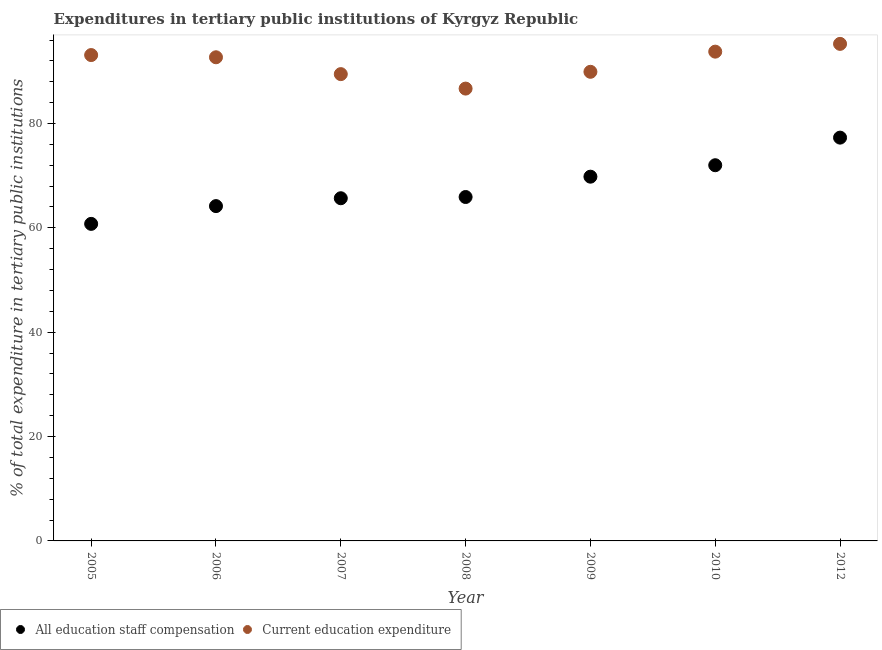Is the number of dotlines equal to the number of legend labels?
Your answer should be very brief. Yes. What is the expenditure in staff compensation in 2005?
Ensure brevity in your answer.  60.76. Across all years, what is the maximum expenditure in staff compensation?
Provide a short and direct response. 77.29. Across all years, what is the minimum expenditure in staff compensation?
Provide a succinct answer. 60.76. In which year was the expenditure in staff compensation maximum?
Your response must be concise. 2012. What is the total expenditure in education in the graph?
Give a very brief answer. 640.92. What is the difference between the expenditure in staff compensation in 2005 and that in 2006?
Provide a short and direct response. -3.41. What is the difference between the expenditure in education in 2007 and the expenditure in staff compensation in 2012?
Keep it short and to the point. 12.17. What is the average expenditure in staff compensation per year?
Give a very brief answer. 67.95. In the year 2005, what is the difference between the expenditure in staff compensation and expenditure in education?
Provide a short and direct response. -32.35. In how many years, is the expenditure in education greater than 48 %?
Your response must be concise. 7. What is the ratio of the expenditure in staff compensation in 2007 to that in 2012?
Give a very brief answer. 0.85. Is the difference between the expenditure in education in 2005 and 2006 greater than the difference between the expenditure in staff compensation in 2005 and 2006?
Provide a short and direct response. Yes. What is the difference between the highest and the second highest expenditure in staff compensation?
Provide a short and direct response. 5.29. What is the difference between the highest and the lowest expenditure in education?
Give a very brief answer. 8.57. In how many years, is the expenditure in staff compensation greater than the average expenditure in staff compensation taken over all years?
Your answer should be very brief. 3. Is the expenditure in staff compensation strictly less than the expenditure in education over the years?
Your answer should be very brief. Yes. How many years are there in the graph?
Offer a terse response. 7. What is the difference between two consecutive major ticks on the Y-axis?
Make the answer very short. 20. Are the values on the major ticks of Y-axis written in scientific E-notation?
Provide a succinct answer. No. Does the graph contain grids?
Your answer should be very brief. No. How many legend labels are there?
Provide a short and direct response. 2. How are the legend labels stacked?
Offer a very short reply. Horizontal. What is the title of the graph?
Offer a very short reply. Expenditures in tertiary public institutions of Kyrgyz Republic. What is the label or title of the X-axis?
Your response must be concise. Year. What is the label or title of the Y-axis?
Provide a succinct answer. % of total expenditure in tertiary public institutions. What is the % of total expenditure in tertiary public institutions in All education staff compensation in 2005?
Provide a succinct answer. 60.76. What is the % of total expenditure in tertiary public institutions of Current education expenditure in 2005?
Offer a terse response. 93.12. What is the % of total expenditure in tertiary public institutions of All education staff compensation in 2006?
Ensure brevity in your answer.  64.17. What is the % of total expenditure in tertiary public institutions of Current education expenditure in 2006?
Your response must be concise. 92.7. What is the % of total expenditure in tertiary public institutions of All education staff compensation in 2007?
Keep it short and to the point. 65.68. What is the % of total expenditure in tertiary public institutions of Current education expenditure in 2007?
Give a very brief answer. 89.47. What is the % of total expenditure in tertiary public institutions in All education staff compensation in 2008?
Offer a terse response. 65.91. What is the % of total expenditure in tertiary public institutions in Current education expenditure in 2008?
Your answer should be very brief. 86.69. What is the % of total expenditure in tertiary public institutions in All education staff compensation in 2009?
Give a very brief answer. 69.81. What is the % of total expenditure in tertiary public institutions of Current education expenditure in 2009?
Your answer should be very brief. 89.91. What is the % of total expenditure in tertiary public institutions of All education staff compensation in 2010?
Make the answer very short. 72.01. What is the % of total expenditure in tertiary public institutions of Current education expenditure in 2010?
Provide a short and direct response. 93.77. What is the % of total expenditure in tertiary public institutions in All education staff compensation in 2012?
Provide a short and direct response. 77.29. What is the % of total expenditure in tertiary public institutions of Current education expenditure in 2012?
Keep it short and to the point. 95.26. Across all years, what is the maximum % of total expenditure in tertiary public institutions of All education staff compensation?
Make the answer very short. 77.29. Across all years, what is the maximum % of total expenditure in tertiary public institutions in Current education expenditure?
Your answer should be very brief. 95.26. Across all years, what is the minimum % of total expenditure in tertiary public institutions of All education staff compensation?
Keep it short and to the point. 60.76. Across all years, what is the minimum % of total expenditure in tertiary public institutions in Current education expenditure?
Provide a succinct answer. 86.69. What is the total % of total expenditure in tertiary public institutions in All education staff compensation in the graph?
Provide a succinct answer. 475.64. What is the total % of total expenditure in tertiary public institutions in Current education expenditure in the graph?
Your response must be concise. 640.92. What is the difference between the % of total expenditure in tertiary public institutions in All education staff compensation in 2005 and that in 2006?
Your response must be concise. -3.41. What is the difference between the % of total expenditure in tertiary public institutions of Current education expenditure in 2005 and that in 2006?
Your answer should be compact. 0.42. What is the difference between the % of total expenditure in tertiary public institutions in All education staff compensation in 2005 and that in 2007?
Keep it short and to the point. -4.91. What is the difference between the % of total expenditure in tertiary public institutions of Current education expenditure in 2005 and that in 2007?
Ensure brevity in your answer.  3.65. What is the difference between the % of total expenditure in tertiary public institutions in All education staff compensation in 2005 and that in 2008?
Your response must be concise. -5.15. What is the difference between the % of total expenditure in tertiary public institutions of Current education expenditure in 2005 and that in 2008?
Your response must be concise. 6.43. What is the difference between the % of total expenditure in tertiary public institutions in All education staff compensation in 2005 and that in 2009?
Make the answer very short. -9.05. What is the difference between the % of total expenditure in tertiary public institutions in Current education expenditure in 2005 and that in 2009?
Ensure brevity in your answer.  3.21. What is the difference between the % of total expenditure in tertiary public institutions of All education staff compensation in 2005 and that in 2010?
Provide a short and direct response. -11.24. What is the difference between the % of total expenditure in tertiary public institutions in Current education expenditure in 2005 and that in 2010?
Your response must be concise. -0.66. What is the difference between the % of total expenditure in tertiary public institutions in All education staff compensation in 2005 and that in 2012?
Provide a short and direct response. -16.53. What is the difference between the % of total expenditure in tertiary public institutions of Current education expenditure in 2005 and that in 2012?
Provide a succinct answer. -2.14. What is the difference between the % of total expenditure in tertiary public institutions of All education staff compensation in 2006 and that in 2007?
Your response must be concise. -1.51. What is the difference between the % of total expenditure in tertiary public institutions in Current education expenditure in 2006 and that in 2007?
Keep it short and to the point. 3.23. What is the difference between the % of total expenditure in tertiary public institutions in All education staff compensation in 2006 and that in 2008?
Offer a very short reply. -1.74. What is the difference between the % of total expenditure in tertiary public institutions of Current education expenditure in 2006 and that in 2008?
Provide a succinct answer. 6. What is the difference between the % of total expenditure in tertiary public institutions of All education staff compensation in 2006 and that in 2009?
Your answer should be compact. -5.64. What is the difference between the % of total expenditure in tertiary public institutions in Current education expenditure in 2006 and that in 2009?
Keep it short and to the point. 2.78. What is the difference between the % of total expenditure in tertiary public institutions in All education staff compensation in 2006 and that in 2010?
Your answer should be compact. -7.83. What is the difference between the % of total expenditure in tertiary public institutions in Current education expenditure in 2006 and that in 2010?
Your response must be concise. -1.08. What is the difference between the % of total expenditure in tertiary public institutions of All education staff compensation in 2006 and that in 2012?
Offer a terse response. -13.12. What is the difference between the % of total expenditure in tertiary public institutions of Current education expenditure in 2006 and that in 2012?
Offer a terse response. -2.57. What is the difference between the % of total expenditure in tertiary public institutions in All education staff compensation in 2007 and that in 2008?
Provide a short and direct response. -0.24. What is the difference between the % of total expenditure in tertiary public institutions in Current education expenditure in 2007 and that in 2008?
Offer a very short reply. 2.77. What is the difference between the % of total expenditure in tertiary public institutions in All education staff compensation in 2007 and that in 2009?
Your answer should be very brief. -4.13. What is the difference between the % of total expenditure in tertiary public institutions of Current education expenditure in 2007 and that in 2009?
Give a very brief answer. -0.45. What is the difference between the % of total expenditure in tertiary public institutions of All education staff compensation in 2007 and that in 2010?
Your answer should be compact. -6.33. What is the difference between the % of total expenditure in tertiary public institutions in Current education expenditure in 2007 and that in 2010?
Your answer should be compact. -4.31. What is the difference between the % of total expenditure in tertiary public institutions of All education staff compensation in 2007 and that in 2012?
Ensure brevity in your answer.  -11.62. What is the difference between the % of total expenditure in tertiary public institutions of Current education expenditure in 2007 and that in 2012?
Your answer should be very brief. -5.8. What is the difference between the % of total expenditure in tertiary public institutions of All education staff compensation in 2008 and that in 2009?
Ensure brevity in your answer.  -3.9. What is the difference between the % of total expenditure in tertiary public institutions in Current education expenditure in 2008 and that in 2009?
Provide a short and direct response. -3.22. What is the difference between the % of total expenditure in tertiary public institutions of All education staff compensation in 2008 and that in 2010?
Ensure brevity in your answer.  -6.09. What is the difference between the % of total expenditure in tertiary public institutions in Current education expenditure in 2008 and that in 2010?
Make the answer very short. -7.08. What is the difference between the % of total expenditure in tertiary public institutions of All education staff compensation in 2008 and that in 2012?
Your answer should be very brief. -11.38. What is the difference between the % of total expenditure in tertiary public institutions of Current education expenditure in 2008 and that in 2012?
Offer a terse response. -8.57. What is the difference between the % of total expenditure in tertiary public institutions of All education staff compensation in 2009 and that in 2010?
Offer a very short reply. -2.19. What is the difference between the % of total expenditure in tertiary public institutions of Current education expenditure in 2009 and that in 2010?
Offer a terse response. -3.86. What is the difference between the % of total expenditure in tertiary public institutions of All education staff compensation in 2009 and that in 2012?
Your answer should be very brief. -7.48. What is the difference between the % of total expenditure in tertiary public institutions in Current education expenditure in 2009 and that in 2012?
Make the answer very short. -5.35. What is the difference between the % of total expenditure in tertiary public institutions of All education staff compensation in 2010 and that in 2012?
Ensure brevity in your answer.  -5.29. What is the difference between the % of total expenditure in tertiary public institutions of Current education expenditure in 2010 and that in 2012?
Offer a very short reply. -1.49. What is the difference between the % of total expenditure in tertiary public institutions of All education staff compensation in 2005 and the % of total expenditure in tertiary public institutions of Current education expenditure in 2006?
Your answer should be very brief. -31.93. What is the difference between the % of total expenditure in tertiary public institutions in All education staff compensation in 2005 and the % of total expenditure in tertiary public institutions in Current education expenditure in 2007?
Give a very brief answer. -28.7. What is the difference between the % of total expenditure in tertiary public institutions in All education staff compensation in 2005 and the % of total expenditure in tertiary public institutions in Current education expenditure in 2008?
Your answer should be compact. -25.93. What is the difference between the % of total expenditure in tertiary public institutions in All education staff compensation in 2005 and the % of total expenditure in tertiary public institutions in Current education expenditure in 2009?
Your answer should be very brief. -29.15. What is the difference between the % of total expenditure in tertiary public institutions in All education staff compensation in 2005 and the % of total expenditure in tertiary public institutions in Current education expenditure in 2010?
Provide a succinct answer. -33.01. What is the difference between the % of total expenditure in tertiary public institutions in All education staff compensation in 2005 and the % of total expenditure in tertiary public institutions in Current education expenditure in 2012?
Your response must be concise. -34.5. What is the difference between the % of total expenditure in tertiary public institutions in All education staff compensation in 2006 and the % of total expenditure in tertiary public institutions in Current education expenditure in 2007?
Provide a short and direct response. -25.29. What is the difference between the % of total expenditure in tertiary public institutions of All education staff compensation in 2006 and the % of total expenditure in tertiary public institutions of Current education expenditure in 2008?
Give a very brief answer. -22.52. What is the difference between the % of total expenditure in tertiary public institutions of All education staff compensation in 2006 and the % of total expenditure in tertiary public institutions of Current education expenditure in 2009?
Offer a very short reply. -25.74. What is the difference between the % of total expenditure in tertiary public institutions in All education staff compensation in 2006 and the % of total expenditure in tertiary public institutions in Current education expenditure in 2010?
Offer a very short reply. -29.6. What is the difference between the % of total expenditure in tertiary public institutions of All education staff compensation in 2006 and the % of total expenditure in tertiary public institutions of Current education expenditure in 2012?
Your answer should be very brief. -31.09. What is the difference between the % of total expenditure in tertiary public institutions of All education staff compensation in 2007 and the % of total expenditure in tertiary public institutions of Current education expenditure in 2008?
Your answer should be compact. -21.01. What is the difference between the % of total expenditure in tertiary public institutions in All education staff compensation in 2007 and the % of total expenditure in tertiary public institutions in Current education expenditure in 2009?
Your answer should be very brief. -24.23. What is the difference between the % of total expenditure in tertiary public institutions in All education staff compensation in 2007 and the % of total expenditure in tertiary public institutions in Current education expenditure in 2010?
Give a very brief answer. -28.1. What is the difference between the % of total expenditure in tertiary public institutions in All education staff compensation in 2007 and the % of total expenditure in tertiary public institutions in Current education expenditure in 2012?
Your response must be concise. -29.58. What is the difference between the % of total expenditure in tertiary public institutions in All education staff compensation in 2008 and the % of total expenditure in tertiary public institutions in Current education expenditure in 2009?
Ensure brevity in your answer.  -24. What is the difference between the % of total expenditure in tertiary public institutions in All education staff compensation in 2008 and the % of total expenditure in tertiary public institutions in Current education expenditure in 2010?
Your answer should be compact. -27.86. What is the difference between the % of total expenditure in tertiary public institutions in All education staff compensation in 2008 and the % of total expenditure in tertiary public institutions in Current education expenditure in 2012?
Offer a terse response. -29.35. What is the difference between the % of total expenditure in tertiary public institutions in All education staff compensation in 2009 and the % of total expenditure in tertiary public institutions in Current education expenditure in 2010?
Your answer should be very brief. -23.96. What is the difference between the % of total expenditure in tertiary public institutions in All education staff compensation in 2009 and the % of total expenditure in tertiary public institutions in Current education expenditure in 2012?
Provide a short and direct response. -25.45. What is the difference between the % of total expenditure in tertiary public institutions of All education staff compensation in 2010 and the % of total expenditure in tertiary public institutions of Current education expenditure in 2012?
Provide a short and direct response. -23.26. What is the average % of total expenditure in tertiary public institutions in All education staff compensation per year?
Your answer should be very brief. 67.95. What is the average % of total expenditure in tertiary public institutions in Current education expenditure per year?
Your answer should be very brief. 91.56. In the year 2005, what is the difference between the % of total expenditure in tertiary public institutions of All education staff compensation and % of total expenditure in tertiary public institutions of Current education expenditure?
Make the answer very short. -32.35. In the year 2006, what is the difference between the % of total expenditure in tertiary public institutions in All education staff compensation and % of total expenditure in tertiary public institutions in Current education expenditure?
Your answer should be very brief. -28.52. In the year 2007, what is the difference between the % of total expenditure in tertiary public institutions in All education staff compensation and % of total expenditure in tertiary public institutions in Current education expenditure?
Provide a succinct answer. -23.79. In the year 2008, what is the difference between the % of total expenditure in tertiary public institutions of All education staff compensation and % of total expenditure in tertiary public institutions of Current education expenditure?
Keep it short and to the point. -20.78. In the year 2009, what is the difference between the % of total expenditure in tertiary public institutions in All education staff compensation and % of total expenditure in tertiary public institutions in Current education expenditure?
Offer a terse response. -20.1. In the year 2010, what is the difference between the % of total expenditure in tertiary public institutions in All education staff compensation and % of total expenditure in tertiary public institutions in Current education expenditure?
Ensure brevity in your answer.  -21.77. In the year 2012, what is the difference between the % of total expenditure in tertiary public institutions in All education staff compensation and % of total expenditure in tertiary public institutions in Current education expenditure?
Your answer should be very brief. -17.97. What is the ratio of the % of total expenditure in tertiary public institutions of All education staff compensation in 2005 to that in 2006?
Offer a terse response. 0.95. What is the ratio of the % of total expenditure in tertiary public institutions of Current education expenditure in 2005 to that in 2006?
Your answer should be very brief. 1. What is the ratio of the % of total expenditure in tertiary public institutions of All education staff compensation in 2005 to that in 2007?
Your response must be concise. 0.93. What is the ratio of the % of total expenditure in tertiary public institutions of Current education expenditure in 2005 to that in 2007?
Your response must be concise. 1.04. What is the ratio of the % of total expenditure in tertiary public institutions in All education staff compensation in 2005 to that in 2008?
Ensure brevity in your answer.  0.92. What is the ratio of the % of total expenditure in tertiary public institutions of Current education expenditure in 2005 to that in 2008?
Provide a succinct answer. 1.07. What is the ratio of the % of total expenditure in tertiary public institutions of All education staff compensation in 2005 to that in 2009?
Give a very brief answer. 0.87. What is the ratio of the % of total expenditure in tertiary public institutions of Current education expenditure in 2005 to that in 2009?
Keep it short and to the point. 1.04. What is the ratio of the % of total expenditure in tertiary public institutions in All education staff compensation in 2005 to that in 2010?
Your response must be concise. 0.84. What is the ratio of the % of total expenditure in tertiary public institutions in Current education expenditure in 2005 to that in 2010?
Your response must be concise. 0.99. What is the ratio of the % of total expenditure in tertiary public institutions of All education staff compensation in 2005 to that in 2012?
Ensure brevity in your answer.  0.79. What is the ratio of the % of total expenditure in tertiary public institutions of Current education expenditure in 2005 to that in 2012?
Provide a short and direct response. 0.98. What is the ratio of the % of total expenditure in tertiary public institutions of Current education expenditure in 2006 to that in 2007?
Your response must be concise. 1.04. What is the ratio of the % of total expenditure in tertiary public institutions in All education staff compensation in 2006 to that in 2008?
Keep it short and to the point. 0.97. What is the ratio of the % of total expenditure in tertiary public institutions of Current education expenditure in 2006 to that in 2008?
Provide a short and direct response. 1.07. What is the ratio of the % of total expenditure in tertiary public institutions of All education staff compensation in 2006 to that in 2009?
Provide a succinct answer. 0.92. What is the ratio of the % of total expenditure in tertiary public institutions of Current education expenditure in 2006 to that in 2009?
Ensure brevity in your answer.  1.03. What is the ratio of the % of total expenditure in tertiary public institutions of All education staff compensation in 2006 to that in 2010?
Keep it short and to the point. 0.89. What is the ratio of the % of total expenditure in tertiary public institutions of Current education expenditure in 2006 to that in 2010?
Your response must be concise. 0.99. What is the ratio of the % of total expenditure in tertiary public institutions of All education staff compensation in 2006 to that in 2012?
Your response must be concise. 0.83. What is the ratio of the % of total expenditure in tertiary public institutions of Current education expenditure in 2006 to that in 2012?
Keep it short and to the point. 0.97. What is the ratio of the % of total expenditure in tertiary public institutions of All education staff compensation in 2007 to that in 2008?
Provide a succinct answer. 1. What is the ratio of the % of total expenditure in tertiary public institutions of Current education expenditure in 2007 to that in 2008?
Ensure brevity in your answer.  1.03. What is the ratio of the % of total expenditure in tertiary public institutions of All education staff compensation in 2007 to that in 2009?
Provide a short and direct response. 0.94. What is the ratio of the % of total expenditure in tertiary public institutions of All education staff compensation in 2007 to that in 2010?
Offer a very short reply. 0.91. What is the ratio of the % of total expenditure in tertiary public institutions of Current education expenditure in 2007 to that in 2010?
Provide a short and direct response. 0.95. What is the ratio of the % of total expenditure in tertiary public institutions of All education staff compensation in 2007 to that in 2012?
Offer a terse response. 0.85. What is the ratio of the % of total expenditure in tertiary public institutions of Current education expenditure in 2007 to that in 2012?
Offer a terse response. 0.94. What is the ratio of the % of total expenditure in tertiary public institutions in All education staff compensation in 2008 to that in 2009?
Give a very brief answer. 0.94. What is the ratio of the % of total expenditure in tertiary public institutions of Current education expenditure in 2008 to that in 2009?
Provide a short and direct response. 0.96. What is the ratio of the % of total expenditure in tertiary public institutions of All education staff compensation in 2008 to that in 2010?
Offer a terse response. 0.92. What is the ratio of the % of total expenditure in tertiary public institutions of Current education expenditure in 2008 to that in 2010?
Your response must be concise. 0.92. What is the ratio of the % of total expenditure in tertiary public institutions of All education staff compensation in 2008 to that in 2012?
Keep it short and to the point. 0.85. What is the ratio of the % of total expenditure in tertiary public institutions of Current education expenditure in 2008 to that in 2012?
Your response must be concise. 0.91. What is the ratio of the % of total expenditure in tertiary public institutions of All education staff compensation in 2009 to that in 2010?
Offer a terse response. 0.97. What is the ratio of the % of total expenditure in tertiary public institutions of Current education expenditure in 2009 to that in 2010?
Ensure brevity in your answer.  0.96. What is the ratio of the % of total expenditure in tertiary public institutions in All education staff compensation in 2009 to that in 2012?
Provide a short and direct response. 0.9. What is the ratio of the % of total expenditure in tertiary public institutions of Current education expenditure in 2009 to that in 2012?
Give a very brief answer. 0.94. What is the ratio of the % of total expenditure in tertiary public institutions in All education staff compensation in 2010 to that in 2012?
Your answer should be compact. 0.93. What is the ratio of the % of total expenditure in tertiary public institutions of Current education expenditure in 2010 to that in 2012?
Provide a succinct answer. 0.98. What is the difference between the highest and the second highest % of total expenditure in tertiary public institutions in All education staff compensation?
Your response must be concise. 5.29. What is the difference between the highest and the second highest % of total expenditure in tertiary public institutions in Current education expenditure?
Offer a very short reply. 1.49. What is the difference between the highest and the lowest % of total expenditure in tertiary public institutions in All education staff compensation?
Make the answer very short. 16.53. What is the difference between the highest and the lowest % of total expenditure in tertiary public institutions in Current education expenditure?
Provide a short and direct response. 8.57. 